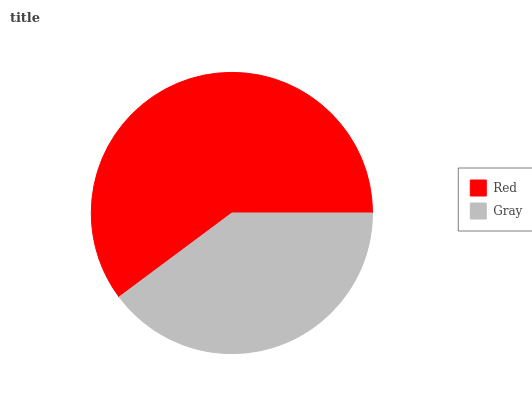Is Gray the minimum?
Answer yes or no. Yes. Is Red the maximum?
Answer yes or no. Yes. Is Gray the maximum?
Answer yes or no. No. Is Red greater than Gray?
Answer yes or no. Yes. Is Gray less than Red?
Answer yes or no. Yes. Is Gray greater than Red?
Answer yes or no. No. Is Red less than Gray?
Answer yes or no. No. Is Red the high median?
Answer yes or no. Yes. Is Gray the low median?
Answer yes or no. Yes. Is Gray the high median?
Answer yes or no. No. Is Red the low median?
Answer yes or no. No. 